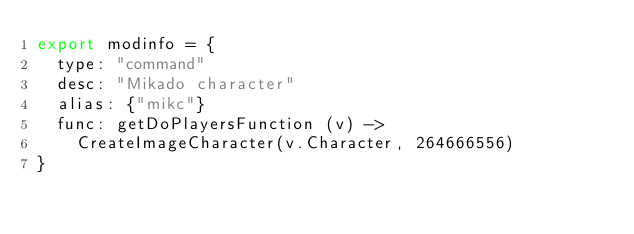<code> <loc_0><loc_0><loc_500><loc_500><_MoonScript_>export modinfo = {
	type: "command"
	desc: "Mikado character"
	alias: {"mikc"}
	func: getDoPlayersFunction (v) ->
		CreateImageCharacter(v.Character, 264666556)
}</code> 